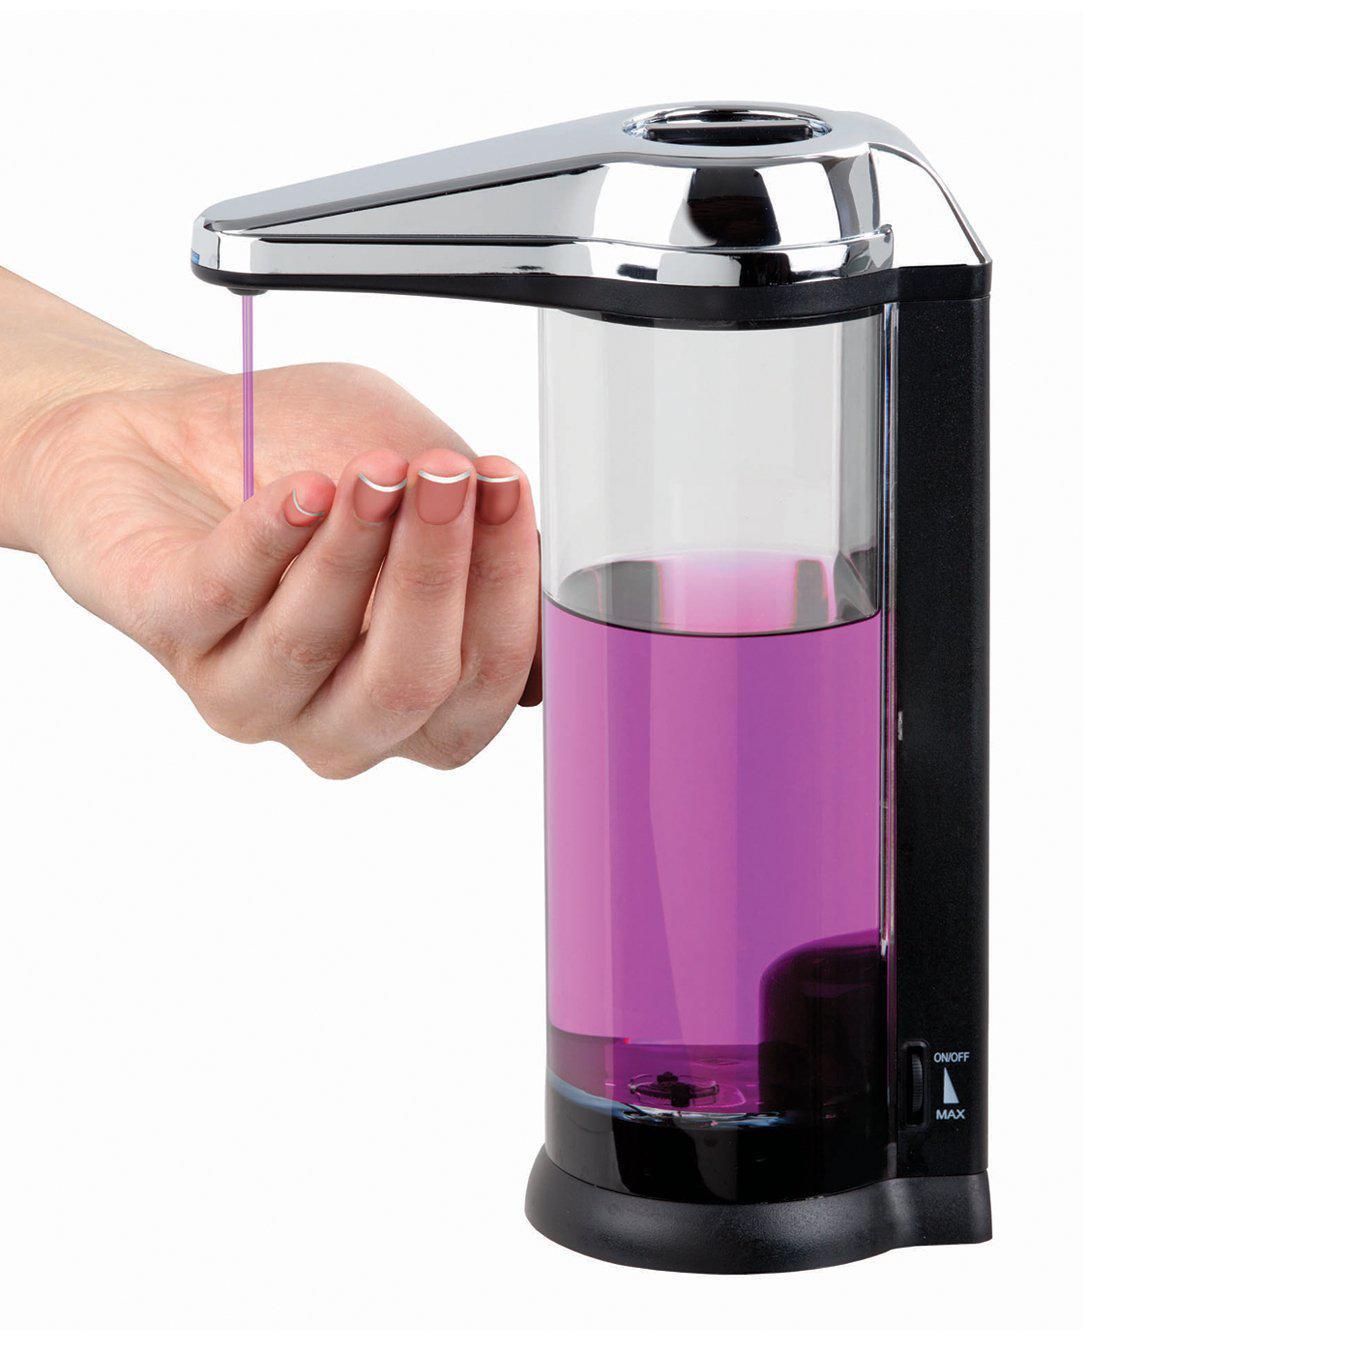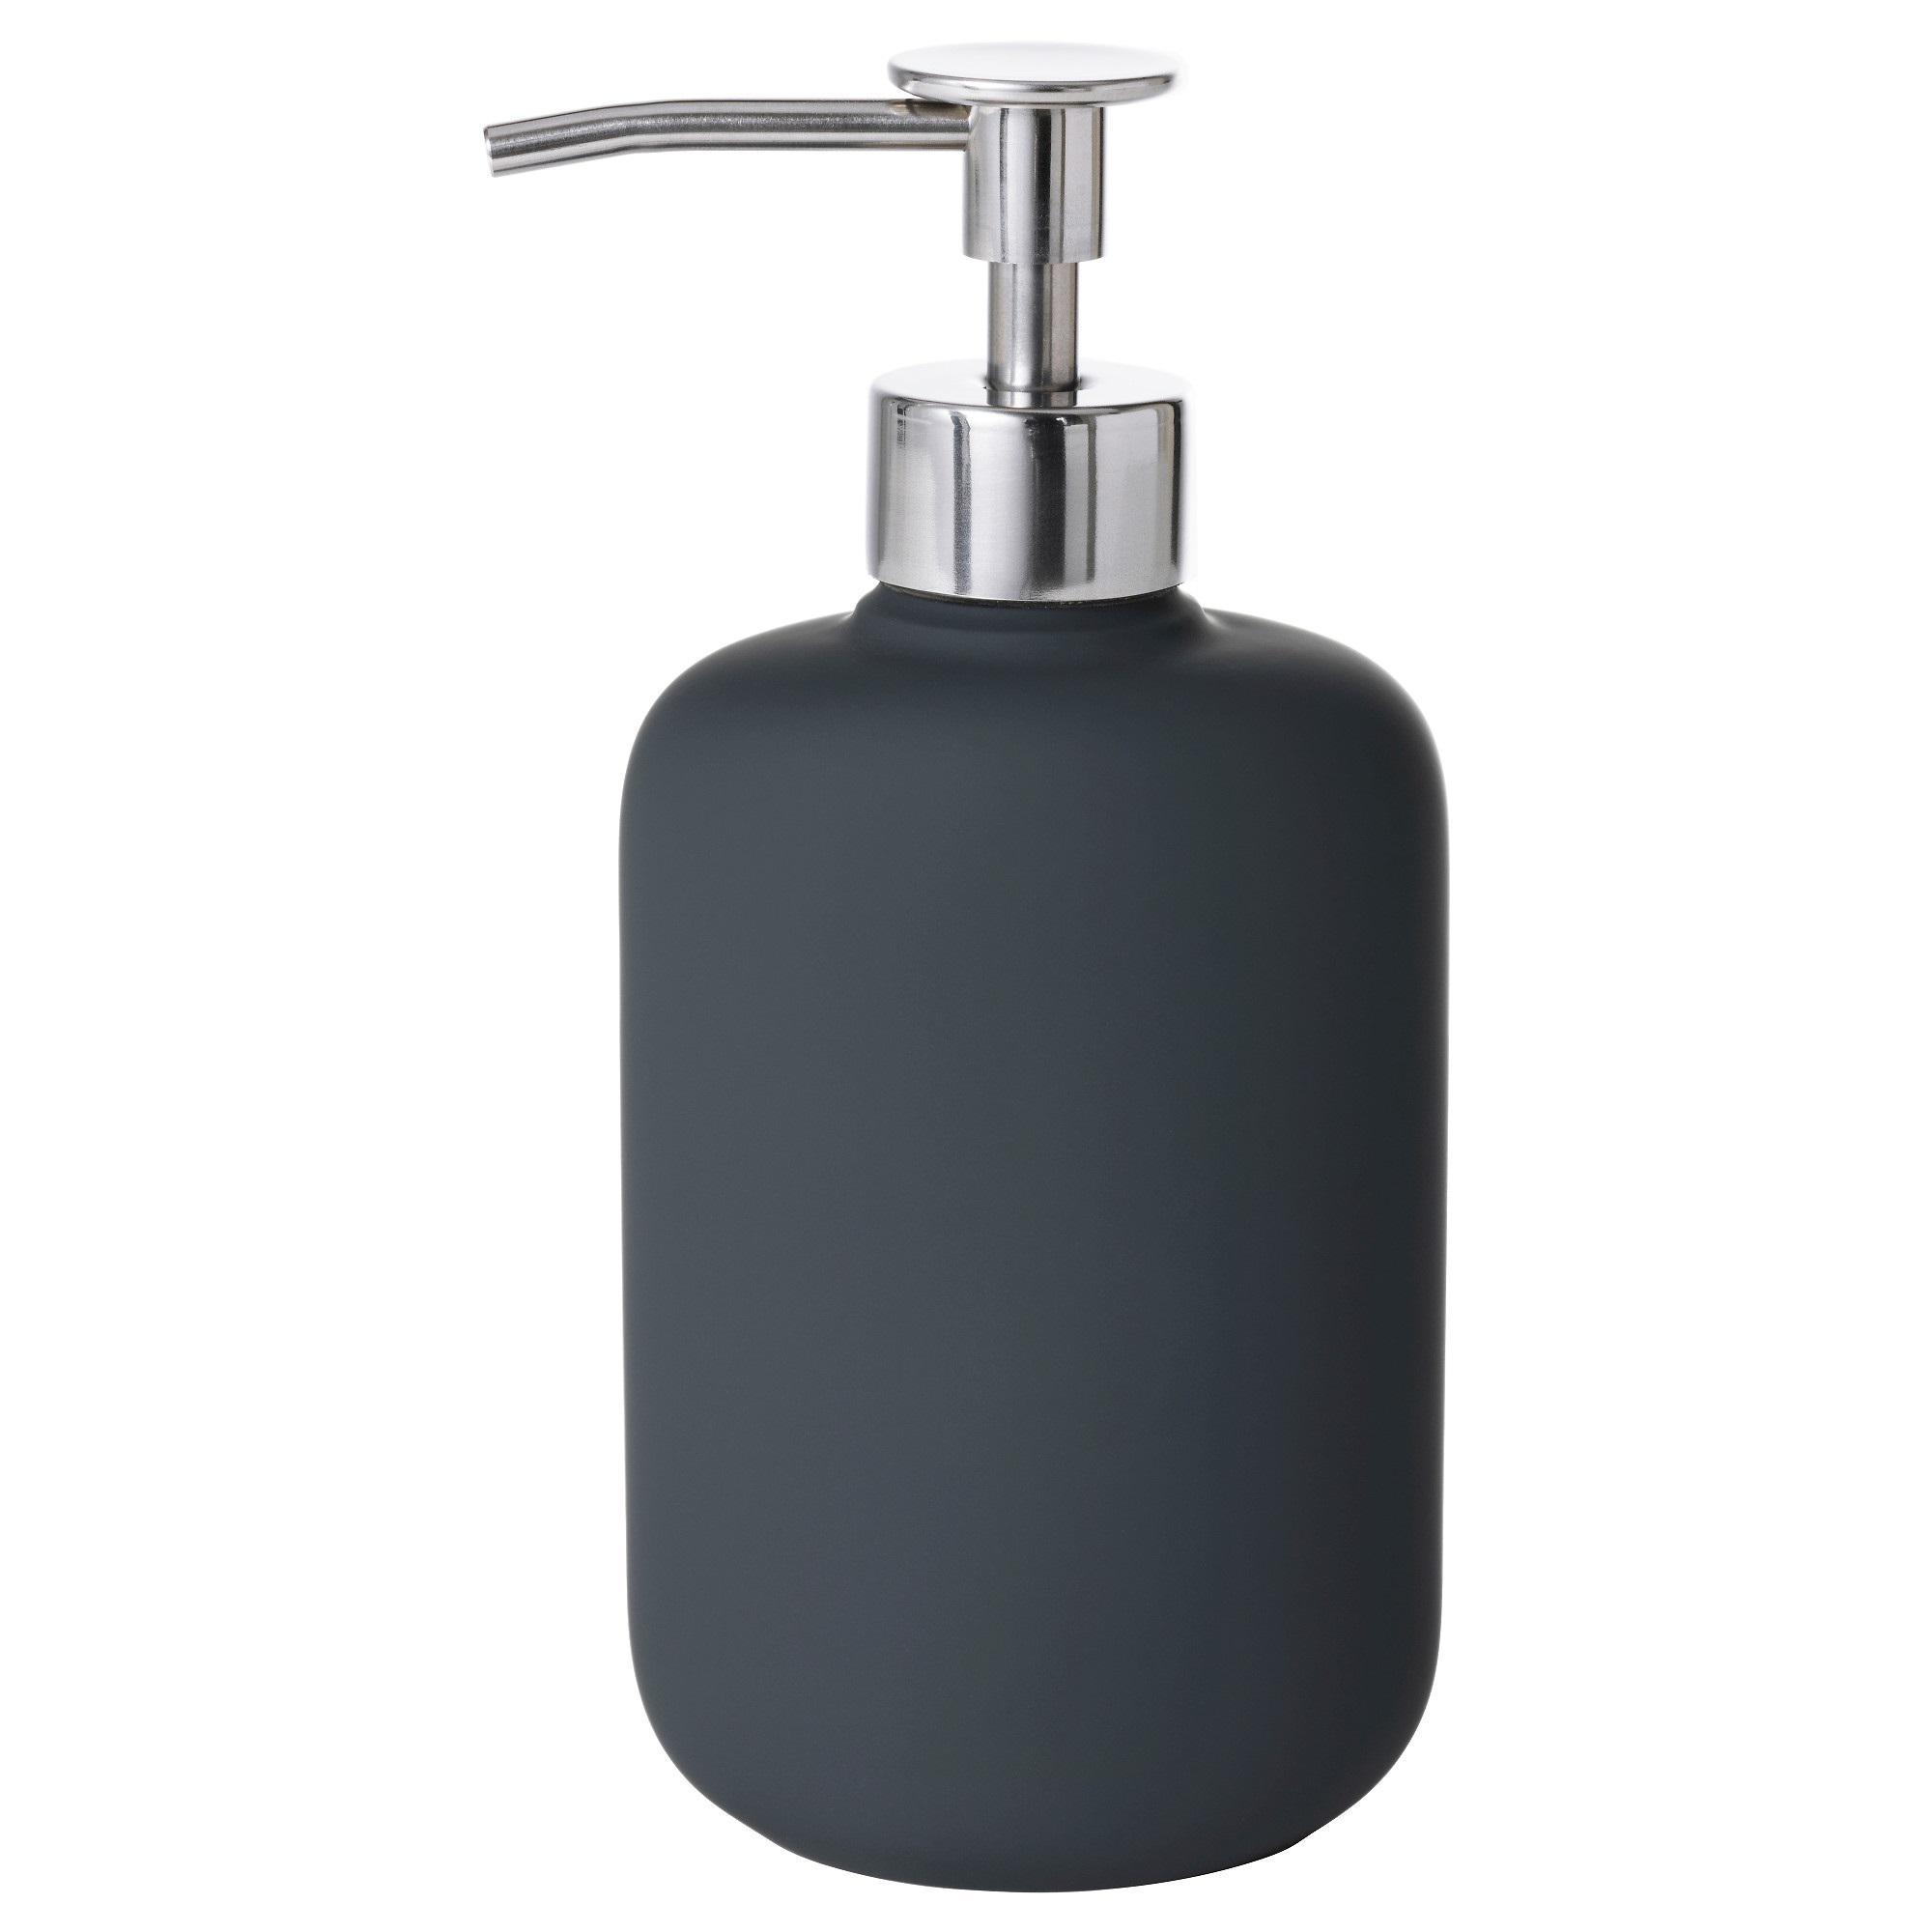The first image is the image on the left, the second image is the image on the right. Evaluate the accuracy of this statement regarding the images: "One image is a standard dispenser with a pump top that does not show the level of the contents.". Is it true? Answer yes or no. Yes. 